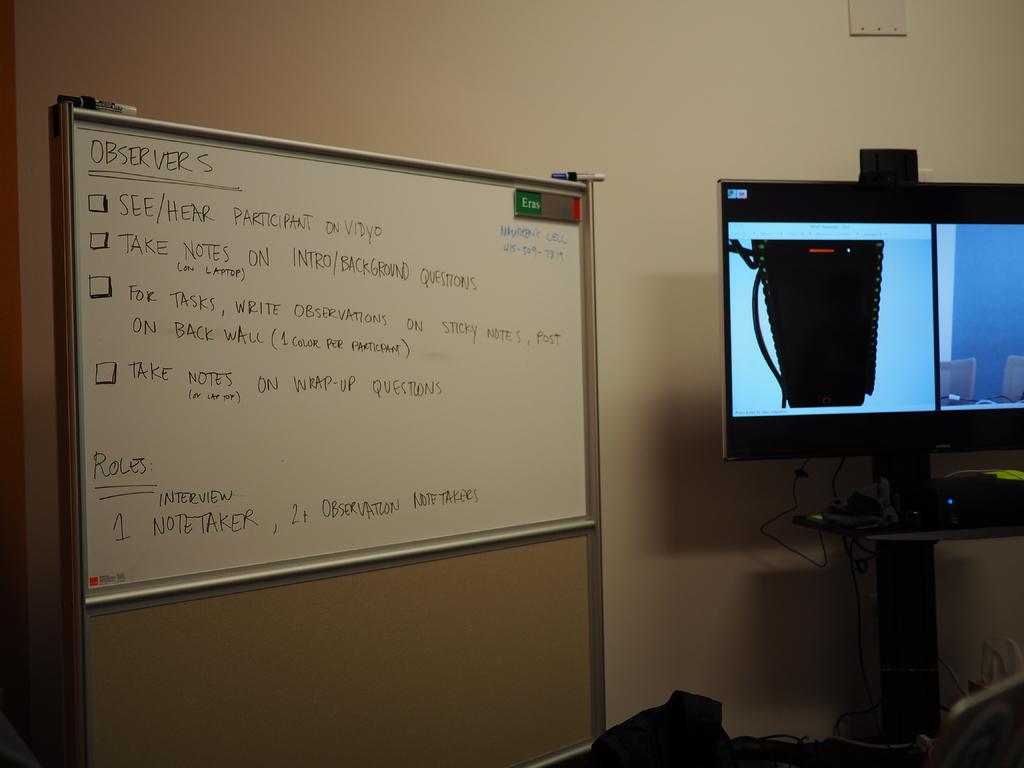What is role number one?
Offer a terse response. Notetaker. What's the last thing written on the board?
Offer a very short reply. Takers. 